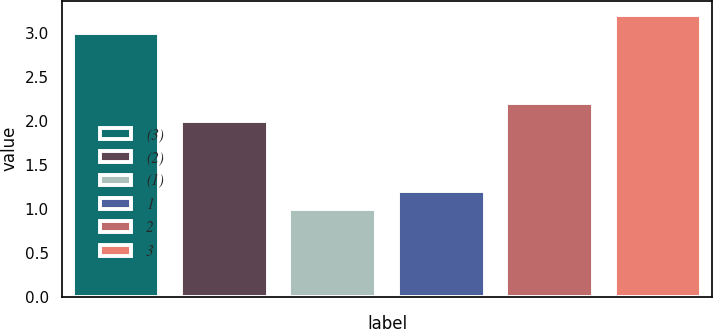Convert chart. <chart><loc_0><loc_0><loc_500><loc_500><bar_chart><fcel>(3)<fcel>(2)<fcel>(1)<fcel>1<fcel>2<fcel>3<nl><fcel>3<fcel>2<fcel>1<fcel>1.2<fcel>2.2<fcel>3.2<nl></chart> 